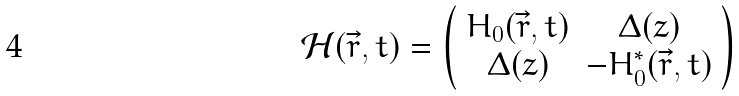<formula> <loc_0><loc_0><loc_500><loc_500>\mathcal { H } ( \vec { r } , t ) = \left ( \begin{array} { c c } H _ { 0 } ( \vec { r } , t ) & \Delta ( z ) \\ \Delta ( z ) & - H _ { 0 } ^ { * } ( \vec { r } , t ) \end{array} \right )</formula> 